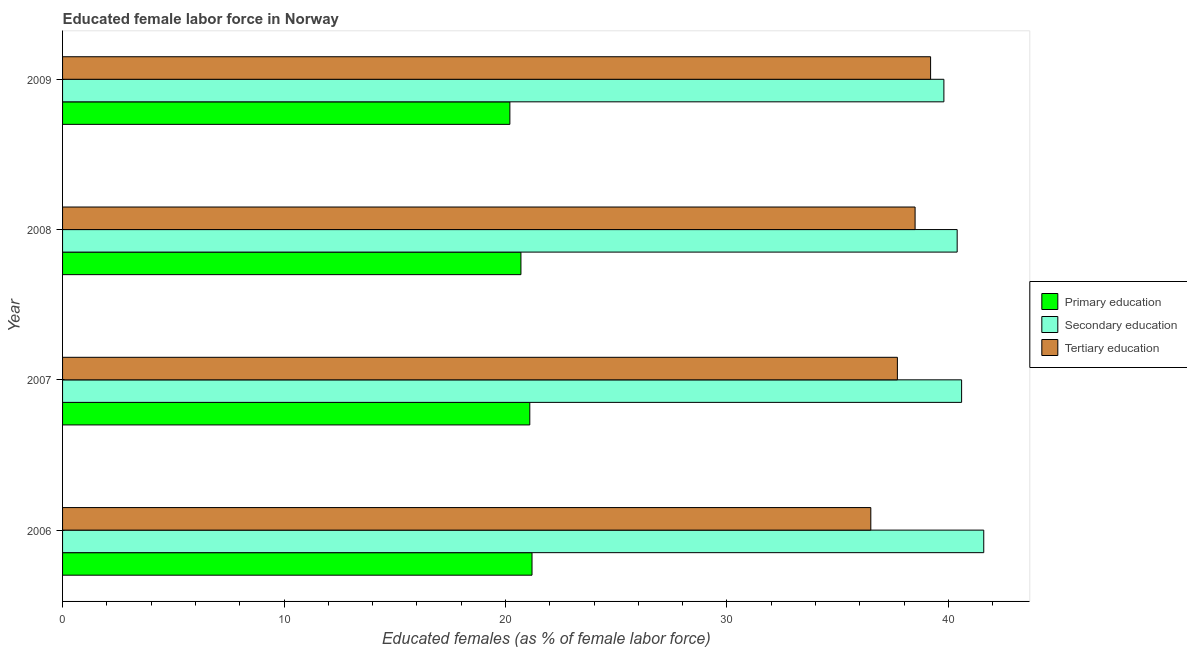How many different coloured bars are there?
Keep it short and to the point. 3. How many groups of bars are there?
Your answer should be compact. 4. How many bars are there on the 2nd tick from the top?
Your answer should be compact. 3. What is the label of the 4th group of bars from the top?
Offer a very short reply. 2006. What is the percentage of female labor force who received secondary education in 2009?
Your response must be concise. 39.8. Across all years, what is the maximum percentage of female labor force who received primary education?
Offer a very short reply. 21.2. Across all years, what is the minimum percentage of female labor force who received primary education?
Keep it short and to the point. 20.2. In which year was the percentage of female labor force who received secondary education minimum?
Provide a succinct answer. 2009. What is the total percentage of female labor force who received tertiary education in the graph?
Provide a short and direct response. 151.9. What is the difference between the percentage of female labor force who received tertiary education in 2006 and that in 2008?
Give a very brief answer. -2. What is the difference between the percentage of female labor force who received secondary education in 2007 and the percentage of female labor force who received primary education in 2008?
Provide a short and direct response. 19.9. What is the average percentage of female labor force who received tertiary education per year?
Provide a succinct answer. 37.98. What is the ratio of the percentage of female labor force who received primary education in 2007 to that in 2008?
Offer a terse response. 1.02. Is the percentage of female labor force who received tertiary education in 2007 less than that in 2008?
Offer a terse response. Yes. What is the difference between the highest and the second highest percentage of female labor force who received primary education?
Give a very brief answer. 0.1. What is the difference between the highest and the lowest percentage of female labor force who received secondary education?
Offer a very short reply. 1.8. What does the 3rd bar from the bottom in 2008 represents?
Offer a very short reply. Tertiary education. How many years are there in the graph?
Ensure brevity in your answer.  4. What is the difference between two consecutive major ticks on the X-axis?
Ensure brevity in your answer.  10. How many legend labels are there?
Make the answer very short. 3. What is the title of the graph?
Provide a succinct answer. Educated female labor force in Norway. Does "Social insurance" appear as one of the legend labels in the graph?
Ensure brevity in your answer.  No. What is the label or title of the X-axis?
Provide a succinct answer. Educated females (as % of female labor force). What is the Educated females (as % of female labor force) of Primary education in 2006?
Your response must be concise. 21.2. What is the Educated females (as % of female labor force) in Secondary education in 2006?
Offer a very short reply. 41.6. What is the Educated females (as % of female labor force) of Tertiary education in 2006?
Your answer should be compact. 36.5. What is the Educated females (as % of female labor force) of Primary education in 2007?
Provide a short and direct response. 21.1. What is the Educated females (as % of female labor force) of Secondary education in 2007?
Provide a short and direct response. 40.6. What is the Educated females (as % of female labor force) in Tertiary education in 2007?
Offer a very short reply. 37.7. What is the Educated females (as % of female labor force) of Primary education in 2008?
Keep it short and to the point. 20.7. What is the Educated females (as % of female labor force) in Secondary education in 2008?
Make the answer very short. 40.4. What is the Educated females (as % of female labor force) of Tertiary education in 2008?
Your response must be concise. 38.5. What is the Educated females (as % of female labor force) of Primary education in 2009?
Your answer should be very brief. 20.2. What is the Educated females (as % of female labor force) of Secondary education in 2009?
Offer a very short reply. 39.8. What is the Educated females (as % of female labor force) in Tertiary education in 2009?
Keep it short and to the point. 39.2. Across all years, what is the maximum Educated females (as % of female labor force) in Primary education?
Ensure brevity in your answer.  21.2. Across all years, what is the maximum Educated females (as % of female labor force) in Secondary education?
Provide a succinct answer. 41.6. Across all years, what is the maximum Educated females (as % of female labor force) in Tertiary education?
Your answer should be compact. 39.2. Across all years, what is the minimum Educated females (as % of female labor force) in Primary education?
Your response must be concise. 20.2. Across all years, what is the minimum Educated females (as % of female labor force) in Secondary education?
Your answer should be very brief. 39.8. Across all years, what is the minimum Educated females (as % of female labor force) in Tertiary education?
Offer a very short reply. 36.5. What is the total Educated females (as % of female labor force) of Primary education in the graph?
Your answer should be very brief. 83.2. What is the total Educated females (as % of female labor force) in Secondary education in the graph?
Your answer should be very brief. 162.4. What is the total Educated females (as % of female labor force) in Tertiary education in the graph?
Your answer should be very brief. 151.9. What is the difference between the Educated females (as % of female labor force) of Primary education in 2006 and that in 2007?
Offer a very short reply. 0.1. What is the difference between the Educated females (as % of female labor force) in Secondary education in 2006 and that in 2007?
Provide a succinct answer. 1. What is the difference between the Educated females (as % of female labor force) in Tertiary education in 2006 and that in 2007?
Make the answer very short. -1.2. What is the difference between the Educated females (as % of female labor force) of Secondary education in 2006 and that in 2008?
Provide a succinct answer. 1.2. What is the difference between the Educated females (as % of female labor force) in Primary education in 2006 and that in 2009?
Offer a very short reply. 1. What is the difference between the Educated females (as % of female labor force) in Primary education in 2007 and that in 2008?
Provide a short and direct response. 0.4. What is the difference between the Educated females (as % of female labor force) of Secondary education in 2007 and that in 2008?
Give a very brief answer. 0.2. What is the difference between the Educated females (as % of female labor force) in Primary education in 2008 and that in 2009?
Give a very brief answer. 0.5. What is the difference between the Educated females (as % of female labor force) of Tertiary education in 2008 and that in 2009?
Provide a succinct answer. -0.7. What is the difference between the Educated females (as % of female labor force) in Primary education in 2006 and the Educated females (as % of female labor force) in Secondary education in 2007?
Make the answer very short. -19.4. What is the difference between the Educated females (as % of female labor force) in Primary education in 2006 and the Educated females (as % of female labor force) in Tertiary education in 2007?
Make the answer very short. -16.5. What is the difference between the Educated females (as % of female labor force) in Primary education in 2006 and the Educated females (as % of female labor force) in Secondary education in 2008?
Give a very brief answer. -19.2. What is the difference between the Educated females (as % of female labor force) of Primary education in 2006 and the Educated females (as % of female labor force) of Tertiary education in 2008?
Offer a terse response. -17.3. What is the difference between the Educated females (as % of female labor force) of Primary education in 2006 and the Educated females (as % of female labor force) of Secondary education in 2009?
Offer a very short reply. -18.6. What is the difference between the Educated females (as % of female labor force) of Primary education in 2007 and the Educated females (as % of female labor force) of Secondary education in 2008?
Keep it short and to the point. -19.3. What is the difference between the Educated females (as % of female labor force) in Primary education in 2007 and the Educated females (as % of female labor force) in Tertiary education in 2008?
Provide a short and direct response. -17.4. What is the difference between the Educated females (as % of female labor force) in Secondary education in 2007 and the Educated females (as % of female labor force) in Tertiary education in 2008?
Provide a succinct answer. 2.1. What is the difference between the Educated females (as % of female labor force) of Primary education in 2007 and the Educated females (as % of female labor force) of Secondary education in 2009?
Provide a succinct answer. -18.7. What is the difference between the Educated females (as % of female labor force) of Primary education in 2007 and the Educated females (as % of female labor force) of Tertiary education in 2009?
Offer a very short reply. -18.1. What is the difference between the Educated females (as % of female labor force) of Primary education in 2008 and the Educated females (as % of female labor force) of Secondary education in 2009?
Your answer should be compact. -19.1. What is the difference between the Educated females (as % of female labor force) in Primary education in 2008 and the Educated females (as % of female labor force) in Tertiary education in 2009?
Your answer should be compact. -18.5. What is the difference between the Educated females (as % of female labor force) of Secondary education in 2008 and the Educated females (as % of female labor force) of Tertiary education in 2009?
Your answer should be very brief. 1.2. What is the average Educated females (as % of female labor force) of Primary education per year?
Ensure brevity in your answer.  20.8. What is the average Educated females (as % of female labor force) of Secondary education per year?
Ensure brevity in your answer.  40.6. What is the average Educated females (as % of female labor force) in Tertiary education per year?
Offer a very short reply. 37.98. In the year 2006, what is the difference between the Educated females (as % of female labor force) in Primary education and Educated females (as % of female labor force) in Secondary education?
Keep it short and to the point. -20.4. In the year 2006, what is the difference between the Educated females (as % of female labor force) in Primary education and Educated females (as % of female labor force) in Tertiary education?
Provide a succinct answer. -15.3. In the year 2006, what is the difference between the Educated females (as % of female labor force) of Secondary education and Educated females (as % of female labor force) of Tertiary education?
Provide a succinct answer. 5.1. In the year 2007, what is the difference between the Educated females (as % of female labor force) in Primary education and Educated females (as % of female labor force) in Secondary education?
Offer a very short reply. -19.5. In the year 2007, what is the difference between the Educated females (as % of female labor force) of Primary education and Educated females (as % of female labor force) of Tertiary education?
Your answer should be very brief. -16.6. In the year 2007, what is the difference between the Educated females (as % of female labor force) in Secondary education and Educated females (as % of female labor force) in Tertiary education?
Ensure brevity in your answer.  2.9. In the year 2008, what is the difference between the Educated females (as % of female labor force) in Primary education and Educated females (as % of female labor force) in Secondary education?
Make the answer very short. -19.7. In the year 2008, what is the difference between the Educated females (as % of female labor force) of Primary education and Educated females (as % of female labor force) of Tertiary education?
Give a very brief answer. -17.8. In the year 2008, what is the difference between the Educated females (as % of female labor force) of Secondary education and Educated females (as % of female labor force) of Tertiary education?
Keep it short and to the point. 1.9. In the year 2009, what is the difference between the Educated females (as % of female labor force) in Primary education and Educated females (as % of female labor force) in Secondary education?
Provide a succinct answer. -19.6. In the year 2009, what is the difference between the Educated females (as % of female labor force) of Primary education and Educated females (as % of female labor force) of Tertiary education?
Your response must be concise. -19. In the year 2009, what is the difference between the Educated females (as % of female labor force) in Secondary education and Educated females (as % of female labor force) in Tertiary education?
Ensure brevity in your answer.  0.6. What is the ratio of the Educated females (as % of female labor force) of Secondary education in 2006 to that in 2007?
Provide a succinct answer. 1.02. What is the ratio of the Educated females (as % of female labor force) of Tertiary education in 2006 to that in 2007?
Provide a short and direct response. 0.97. What is the ratio of the Educated females (as % of female labor force) of Primary education in 2006 to that in 2008?
Offer a very short reply. 1.02. What is the ratio of the Educated females (as % of female labor force) in Secondary education in 2006 to that in 2008?
Make the answer very short. 1.03. What is the ratio of the Educated females (as % of female labor force) of Tertiary education in 2006 to that in 2008?
Give a very brief answer. 0.95. What is the ratio of the Educated females (as % of female labor force) of Primary education in 2006 to that in 2009?
Keep it short and to the point. 1.05. What is the ratio of the Educated females (as % of female labor force) in Secondary education in 2006 to that in 2009?
Your response must be concise. 1.05. What is the ratio of the Educated females (as % of female labor force) in Tertiary education in 2006 to that in 2009?
Your answer should be compact. 0.93. What is the ratio of the Educated females (as % of female labor force) in Primary education in 2007 to that in 2008?
Your answer should be compact. 1.02. What is the ratio of the Educated females (as % of female labor force) of Tertiary education in 2007 to that in 2008?
Provide a short and direct response. 0.98. What is the ratio of the Educated females (as % of female labor force) of Primary education in 2007 to that in 2009?
Give a very brief answer. 1.04. What is the ratio of the Educated females (as % of female labor force) of Secondary education in 2007 to that in 2009?
Offer a terse response. 1.02. What is the ratio of the Educated females (as % of female labor force) of Tertiary education in 2007 to that in 2009?
Keep it short and to the point. 0.96. What is the ratio of the Educated females (as % of female labor force) in Primary education in 2008 to that in 2009?
Your answer should be compact. 1.02. What is the ratio of the Educated females (as % of female labor force) of Secondary education in 2008 to that in 2009?
Offer a very short reply. 1.02. What is the ratio of the Educated females (as % of female labor force) in Tertiary education in 2008 to that in 2009?
Provide a short and direct response. 0.98. What is the difference between the highest and the second highest Educated females (as % of female labor force) of Secondary education?
Offer a very short reply. 1. What is the difference between the highest and the second highest Educated females (as % of female labor force) of Tertiary education?
Your answer should be very brief. 0.7. What is the difference between the highest and the lowest Educated females (as % of female labor force) in Primary education?
Provide a short and direct response. 1. What is the difference between the highest and the lowest Educated females (as % of female labor force) of Secondary education?
Ensure brevity in your answer.  1.8. What is the difference between the highest and the lowest Educated females (as % of female labor force) of Tertiary education?
Keep it short and to the point. 2.7. 